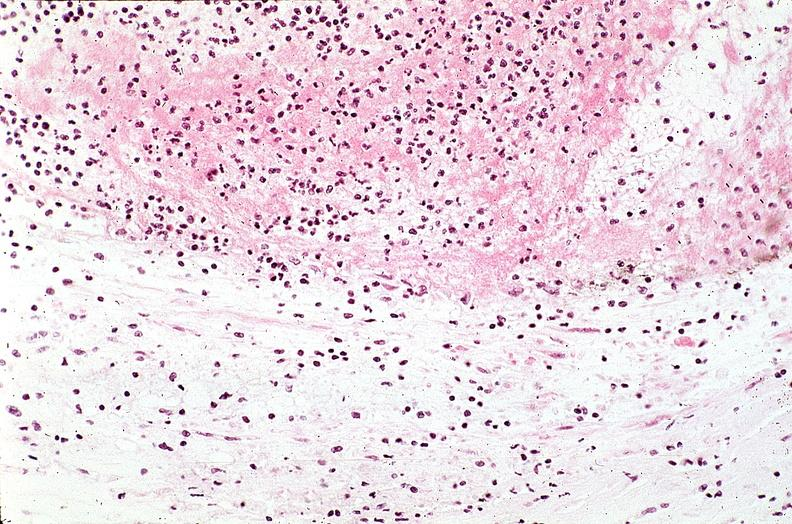what is present?
Answer the question using a single word or phrase. Cardiovascular 